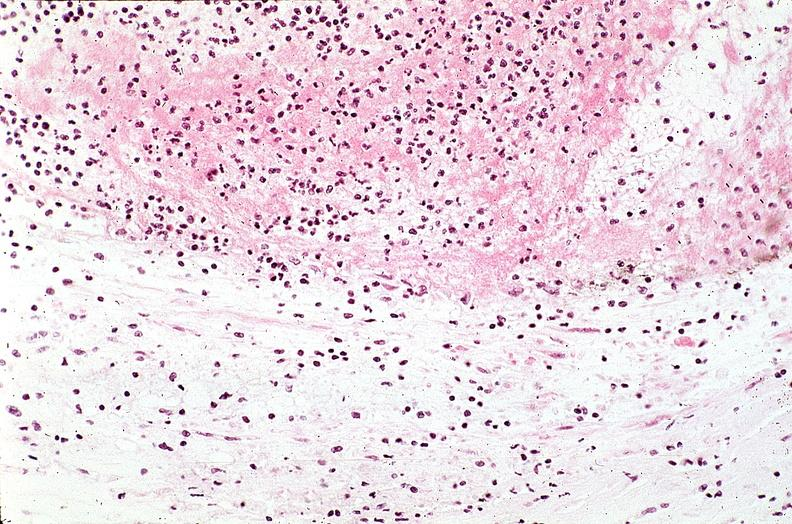what is present?
Answer the question using a single word or phrase. Cardiovascular 